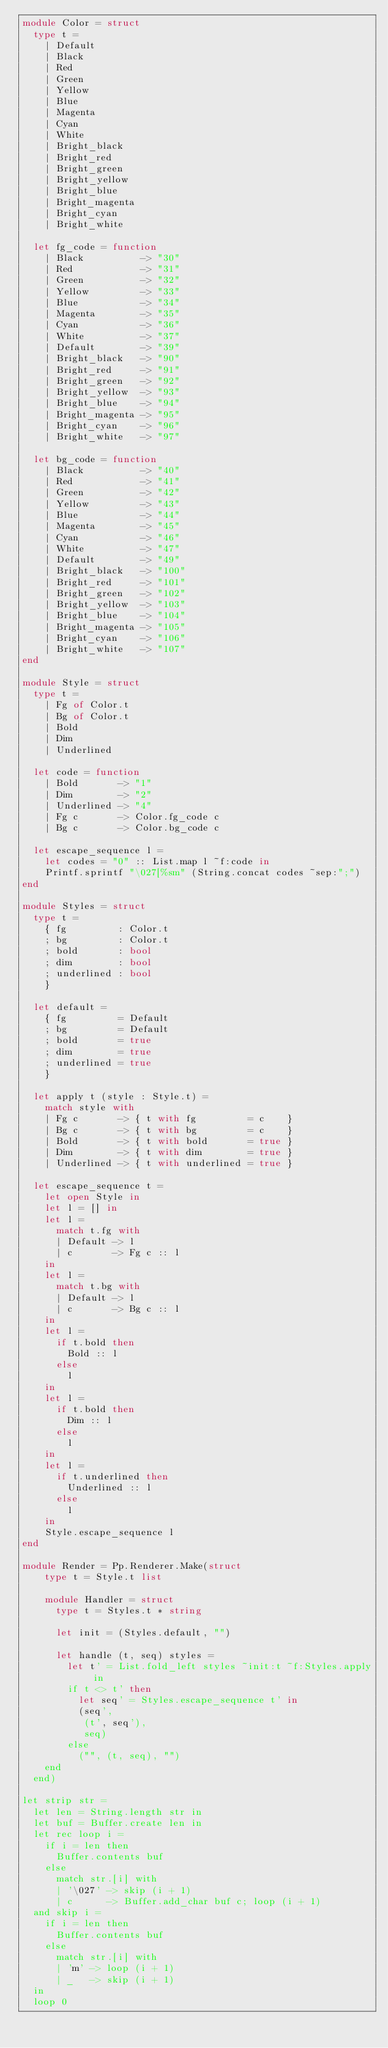<code> <loc_0><loc_0><loc_500><loc_500><_OCaml_>module Color = struct
  type t =
    | Default
    | Black
    | Red
    | Green
    | Yellow
    | Blue
    | Magenta
    | Cyan
    | White
    | Bright_black
    | Bright_red
    | Bright_green
    | Bright_yellow
    | Bright_blue
    | Bright_magenta
    | Bright_cyan
    | Bright_white

  let fg_code = function
    | Black          -> "30"
    | Red            -> "31"
    | Green          -> "32"
    | Yellow         -> "33"
    | Blue           -> "34"
    | Magenta        -> "35"
    | Cyan           -> "36"
    | White          -> "37"
    | Default        -> "39"
    | Bright_black   -> "90"
    | Bright_red     -> "91"
    | Bright_green   -> "92"
    | Bright_yellow  -> "93"
    | Bright_blue    -> "94"
    | Bright_magenta -> "95"
    | Bright_cyan    -> "96"
    | Bright_white   -> "97"

  let bg_code = function
    | Black          -> "40"
    | Red            -> "41"
    | Green          -> "42"
    | Yellow         -> "43"
    | Blue           -> "44"
    | Magenta        -> "45"
    | Cyan           -> "46"
    | White          -> "47"
    | Default        -> "49"
    | Bright_black   -> "100"
    | Bright_red     -> "101"
    | Bright_green   -> "102"
    | Bright_yellow  -> "103"
    | Bright_blue    -> "104"
    | Bright_magenta -> "105"
    | Bright_cyan    -> "106"
    | Bright_white   -> "107"
end

module Style = struct
  type t =
    | Fg of Color.t
    | Bg of Color.t
    | Bold
    | Dim
    | Underlined

  let code = function
    | Bold       -> "1"
    | Dim        -> "2"
    | Underlined -> "4"
    | Fg c       -> Color.fg_code c
    | Bg c       -> Color.bg_code c

  let escape_sequence l =
    let codes = "0" :: List.map l ~f:code in
    Printf.sprintf "\027[%sm" (String.concat codes ~sep:";")
end

module Styles = struct
  type t =
    { fg         : Color.t
    ; bg         : Color.t
    ; bold       : bool
    ; dim        : bool
    ; underlined : bool
    }

  let default =
    { fg         = Default
    ; bg         = Default
    ; bold       = true
    ; dim        = true
    ; underlined = true
    }

  let apply t (style : Style.t) =
    match style with
    | Fg c       -> { t with fg         = c    }
    | Bg c       -> { t with bg         = c    }
    | Bold       -> { t with bold       = true }
    | Dim        -> { t with dim        = true }
    | Underlined -> { t with underlined = true }

  let escape_sequence t =
    let open Style in
    let l = [] in
    let l =
      match t.fg with
      | Default -> l
      | c       -> Fg c :: l
    in
    let l =
      match t.bg with
      | Default -> l
      | c       -> Bg c :: l
    in
    let l =
      if t.bold then
        Bold :: l
      else
        l
    in
    let l =
      if t.bold then
        Dim :: l
      else
        l
    in
    let l =
      if t.underlined then
        Underlined :: l
      else
        l
    in
    Style.escape_sequence l
end

module Render = Pp.Renderer.Make(struct
    type t = Style.t list

    module Handler = struct
      type t = Styles.t * string

      let init = (Styles.default, "")

      let handle (t, seq) styles =
        let t' = List.fold_left styles ~init:t ~f:Styles.apply in
        if t <> t' then
          let seq' = Styles.escape_sequence t' in
          (seq',
           (t', seq'),
           seq)
        else
          ("", (t, seq), "")
    end
  end)

let strip str =
  let len = String.length str in
  let buf = Buffer.create len in
  let rec loop i =
    if i = len then
      Buffer.contents buf
    else
      match str.[i] with
      | '\027' -> skip (i + 1)
      | c      -> Buffer.add_char buf c; loop (i + 1)
  and skip i =
    if i = len then
      Buffer.contents buf
    else
      match str.[i] with
      | 'm' -> loop (i + 1)
      | _   -> skip (i + 1)
  in
  loop 0
</code> 